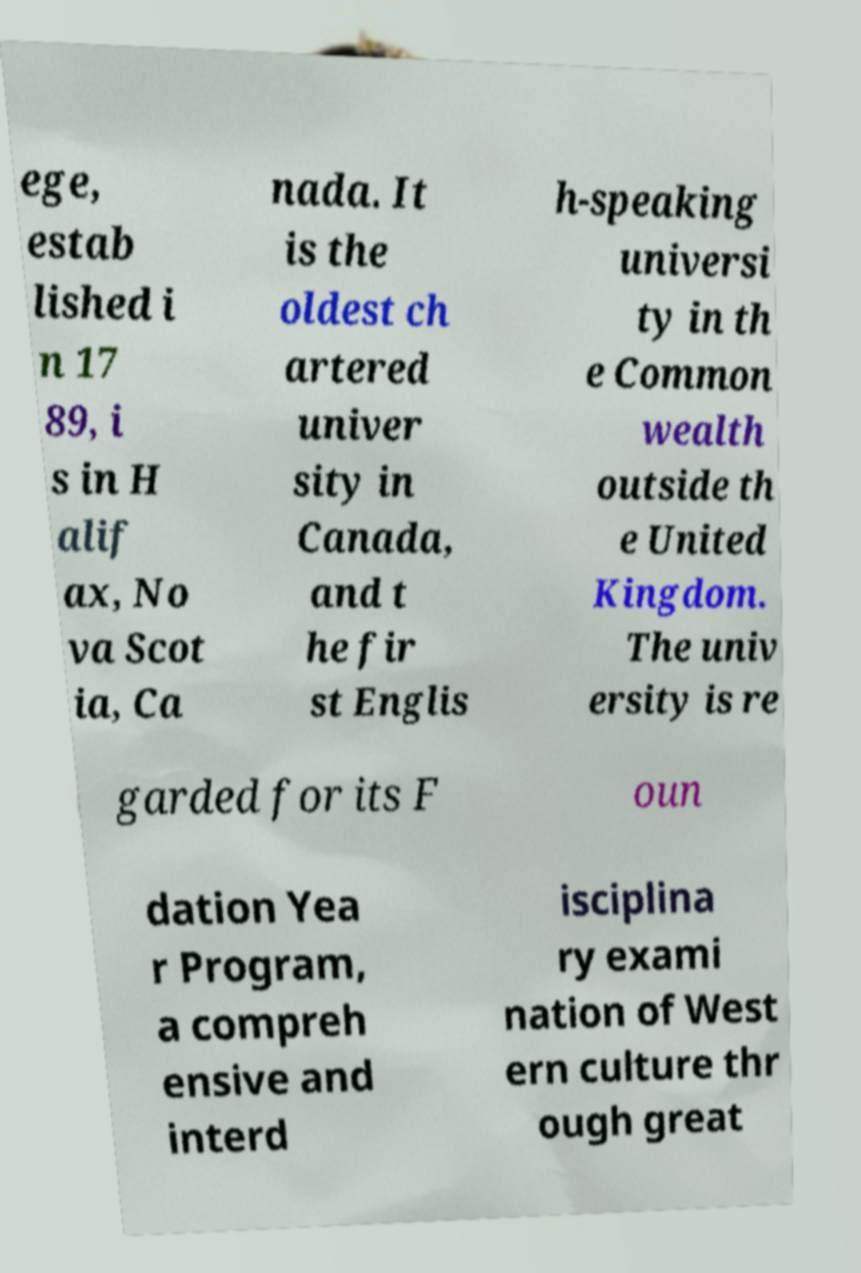What messages or text are displayed in this image? I need them in a readable, typed format. ege, estab lished i n 17 89, i s in H alif ax, No va Scot ia, Ca nada. It is the oldest ch artered univer sity in Canada, and t he fir st Englis h-speaking universi ty in th e Common wealth outside th e United Kingdom. The univ ersity is re garded for its F oun dation Yea r Program, a compreh ensive and interd isciplina ry exami nation of West ern culture thr ough great 